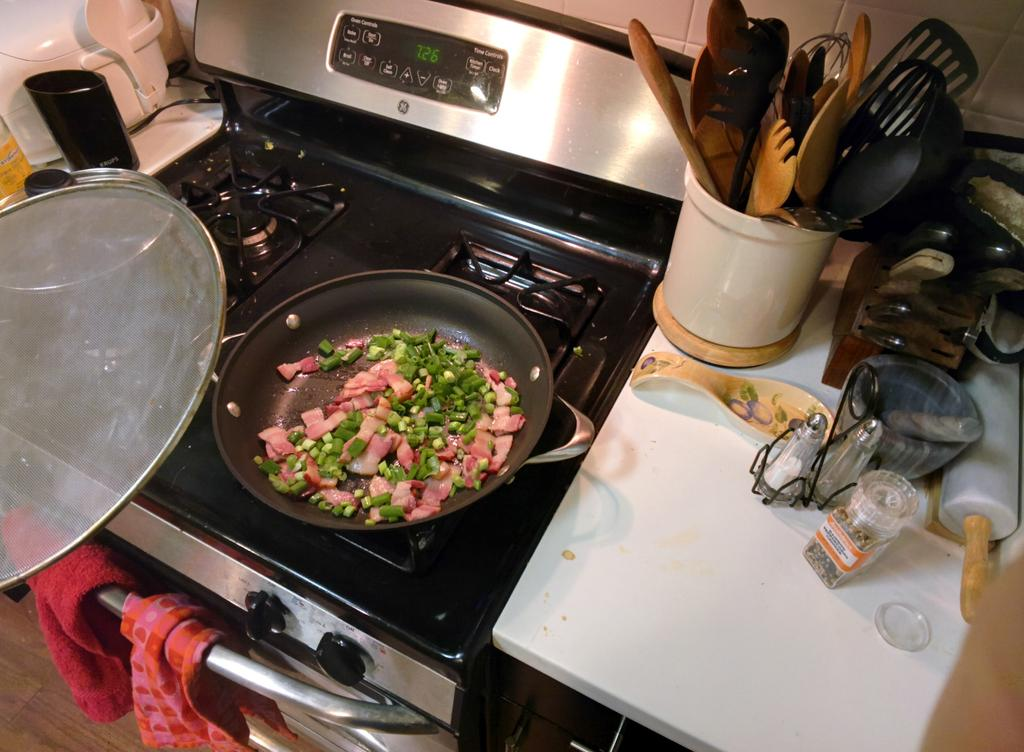<image>
Describe the image concisely. a meal of a meat and greens cooking on a stove at 726 